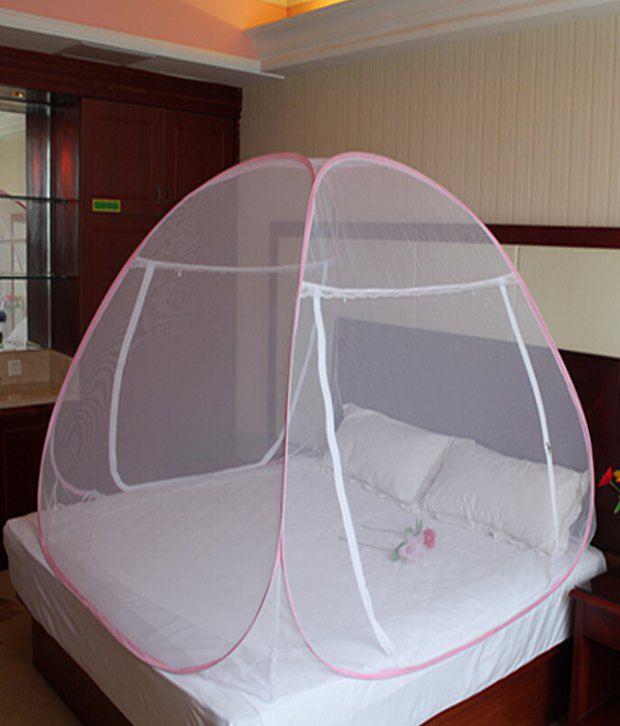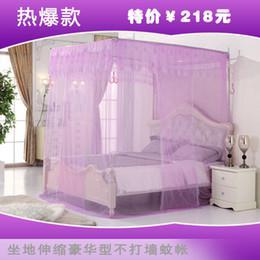The first image is the image on the left, the second image is the image on the right. Evaluate the accuracy of this statement regarding the images: "One image shows a ceiling-suspended gauzy canopy over a bed.". Is it true? Answer yes or no. No. 